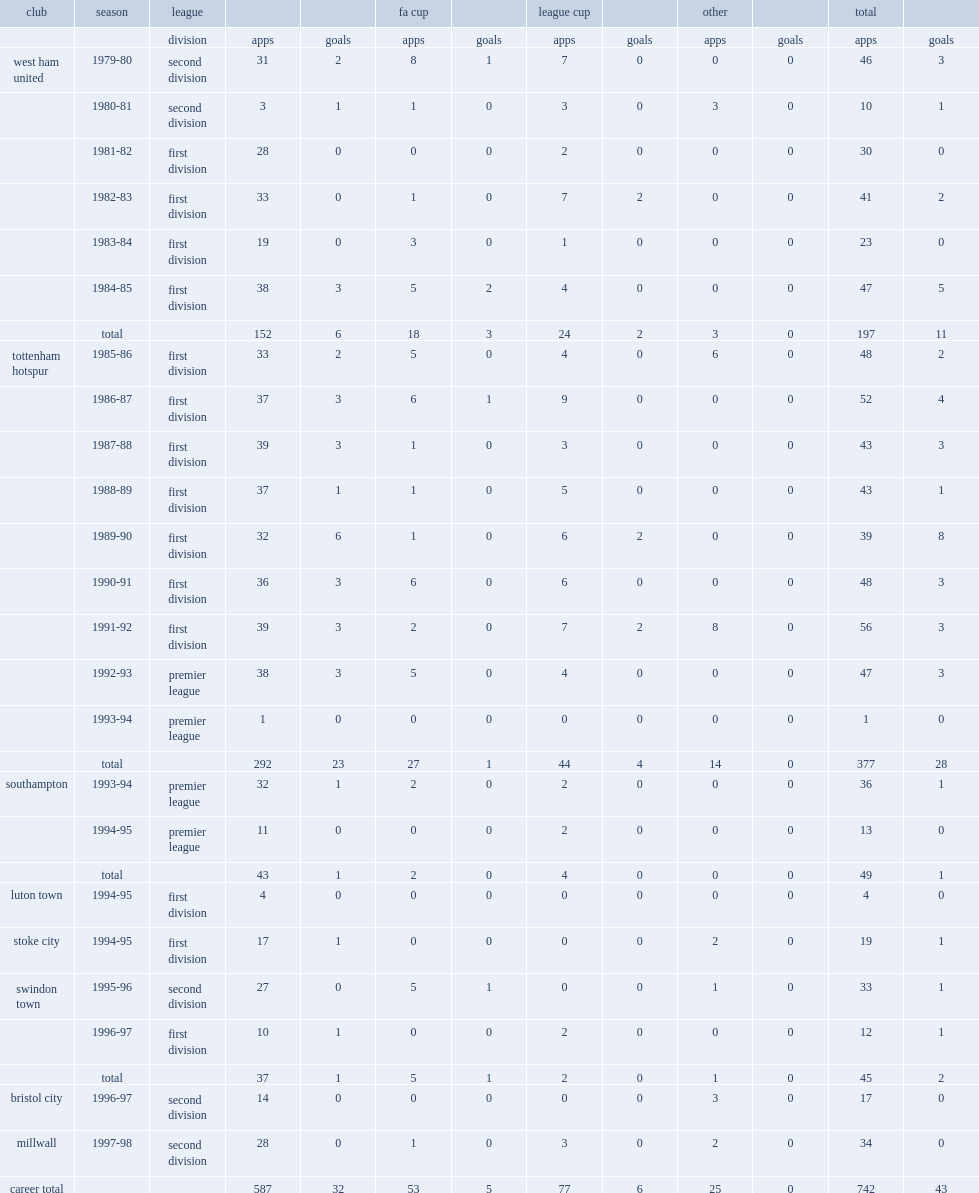How many league goals did paul allen play for tottenham totally? 23.0. 